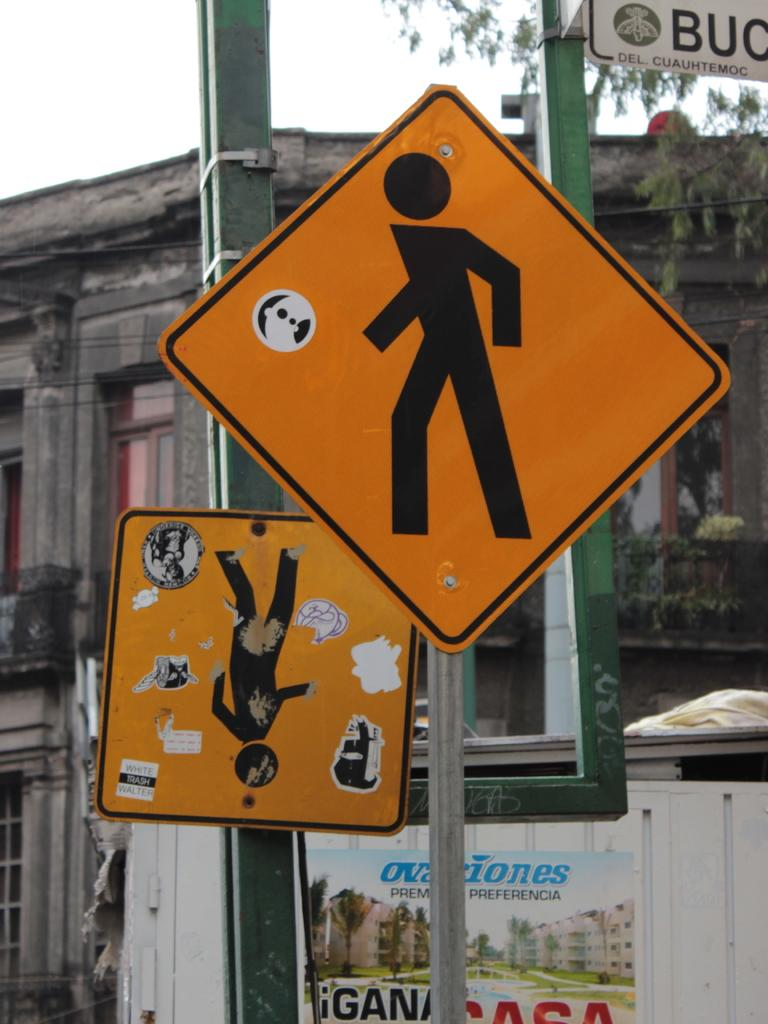<image>
Create a compact narrative representing the image presented. A city street is lined with signs where one says preferencia and a sign that says del, cuauhtemoc on it. 